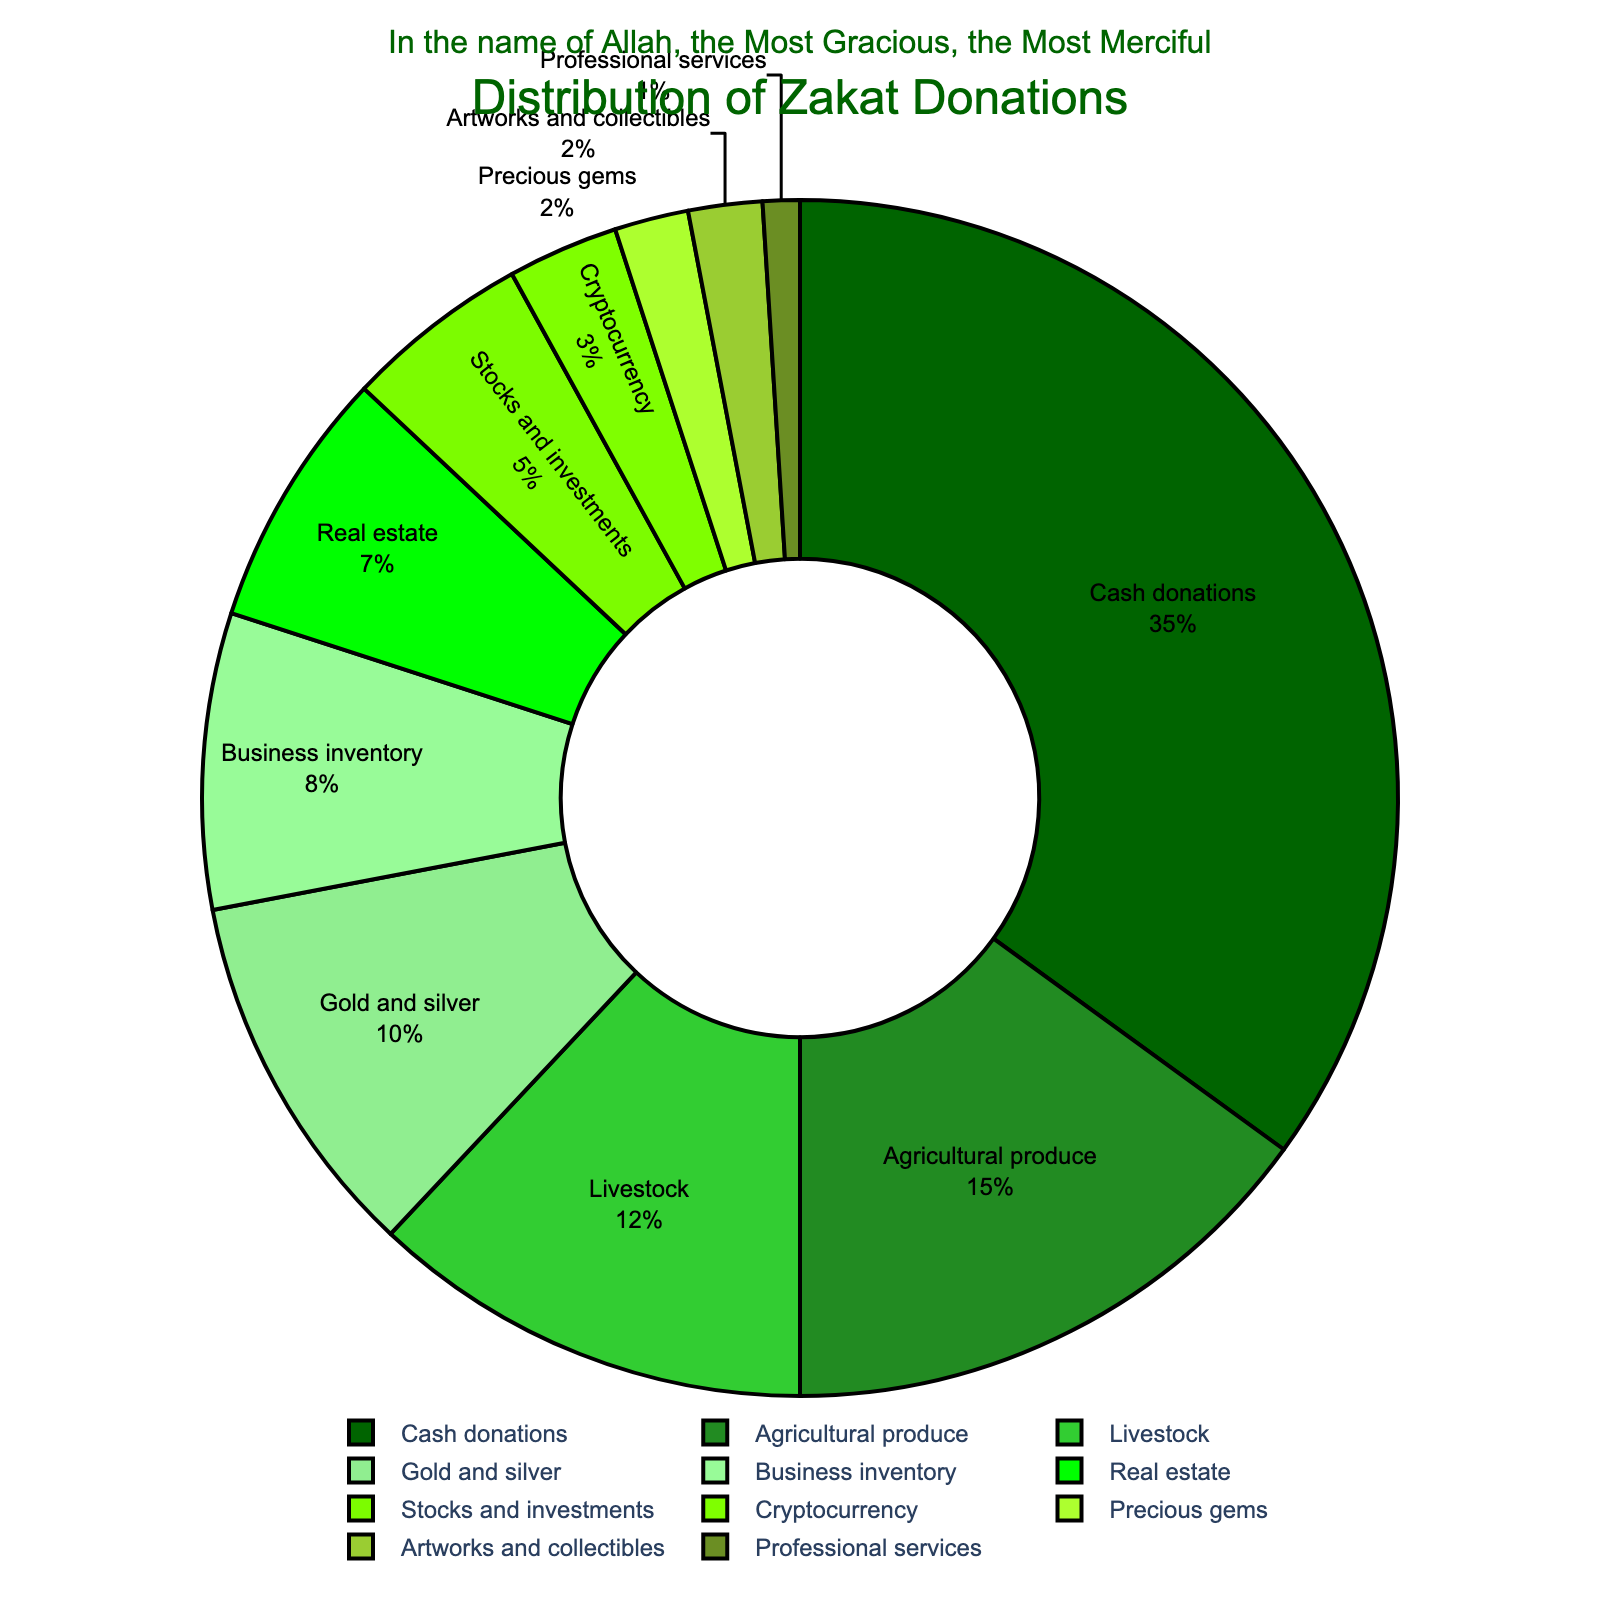What category has the highest proportion of Zakat donations? By looking at the pie chart, the category with the largest section will have the highest proportion. The largest section is "Cash donations".
Answer: Cash donations What is the total percentage for agricultural produce, livestock, and gold and silver combined? Sum the percentages for agricultural produce (15%), livestock (12%), and gold and silver (10%). The total is 15 + 12 + 10.
Answer: 37 Which category has a lower proportion: business inventory or cryptocurrency? By comparing the two sections of the pie chart, we see that cryptocurrency (3%) has a lower proportion than business inventory (8%).
Answer: Cryptocurrency How many categories have a proportion of 10% or more? Count the sections of the pie chart with 10% or more: Cash donations (35%), Agricultural produce (15%), Livestock (12%), Gold and silver (10%). This gives us four categories.
Answer: 4 What is the difference in percentages between cash donations and real estate? Subtract the percentage of real estate (7%) from the percentage of cash donations (35%). The difference is 35 - 7.
Answer: 28 Which categories have less than 5% of the total Zakat donations? Identify all sections less than 5%: Stocks and investments (5%), Cryptocurrency (3%), Precious gems (2%), Artworks and collectibles (2%), Professional services (1%).
Answer: 5 What is the average percentage of stocks and investments, cryptocurrency, and precious gems? Sum the percentages of stocks and investments (5%), cryptocurrency (3%), and precious gems (2%) and divide by 3. The calculation is (5 + 3 + 2) / 3.
Answer: 3.33 Is the proportion of agricultural produce greater than the combined proportion of artworks and collectibles and professional services? Sum the percentages for artworks and collectibles (2%) and professional services (1%), which equals 3%. Compare with agricultural produce (15%). Yes, 15% is greater than 3%.
Answer: Yes What proportion of Zakat donations comes from non-traditional categories like cryptocurrency, precious gems, and artworks and collectibles combined? Sum the percentages for cryptocurrency (3%), precious gems (2%), and artworks and collectibles (2%). The total is 3 + 2 + 2.
Answer: 7 